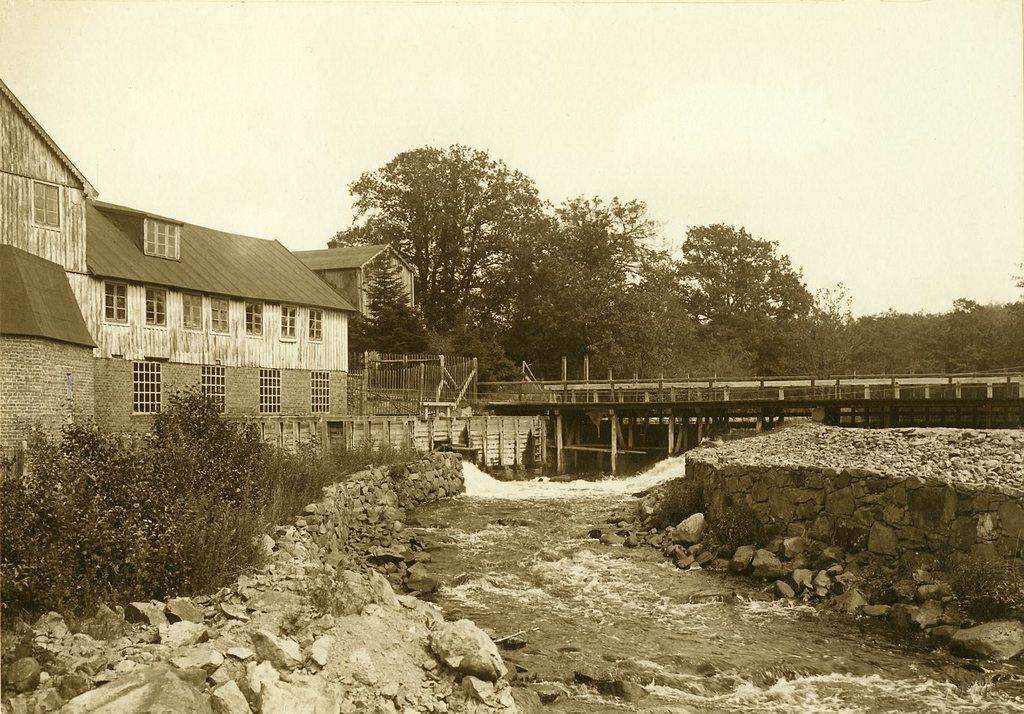How would you summarize this image in a sentence or two? In this picture in the front there are stones. In the center there is water, there are plants. In the background there are houses, there is a bridge, there is a fence and there are trees and at the top there is sky. 